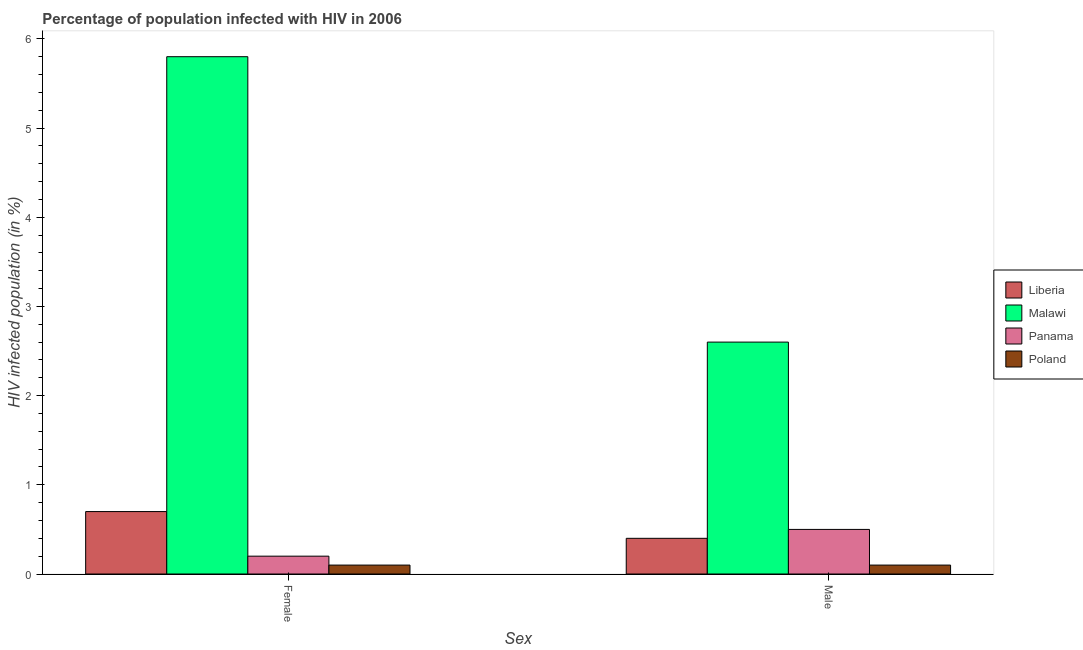Are the number of bars per tick equal to the number of legend labels?
Offer a very short reply. Yes. Are the number of bars on each tick of the X-axis equal?
Make the answer very short. Yes. How many bars are there on the 2nd tick from the left?
Your answer should be compact. 4. What is the label of the 2nd group of bars from the left?
Provide a succinct answer. Male. Across all countries, what is the minimum percentage of females who are infected with hiv?
Your answer should be compact. 0.1. In which country was the percentage of females who are infected with hiv maximum?
Make the answer very short. Malawi. In which country was the percentage of males who are infected with hiv minimum?
Give a very brief answer. Poland. What is the difference between the percentage of males who are infected with hiv in Poland and that in Liberia?
Provide a short and direct response. -0.3. What is the difference between the percentage of females who are infected with hiv in Liberia and the percentage of males who are infected with hiv in Panama?
Offer a very short reply. 0.2. What is the average percentage of females who are infected with hiv per country?
Your response must be concise. 1.7. In how many countries, is the percentage of females who are infected with hiv greater than 4.4 %?
Provide a short and direct response. 1. What is the ratio of the percentage of females who are infected with hiv in Malawi to that in Panama?
Offer a terse response. 29. In how many countries, is the percentage of males who are infected with hiv greater than the average percentage of males who are infected with hiv taken over all countries?
Your answer should be compact. 1. What does the 1st bar from the left in Female represents?
Offer a terse response. Liberia. What does the 3rd bar from the right in Male represents?
Offer a very short reply. Malawi. Are the values on the major ticks of Y-axis written in scientific E-notation?
Your answer should be very brief. No. What is the title of the graph?
Ensure brevity in your answer.  Percentage of population infected with HIV in 2006. Does "Korea (Democratic)" appear as one of the legend labels in the graph?
Keep it short and to the point. No. What is the label or title of the X-axis?
Provide a short and direct response. Sex. What is the label or title of the Y-axis?
Ensure brevity in your answer.  HIV infected population (in %). What is the HIV infected population (in %) of Malawi in Female?
Make the answer very short. 5.8. What is the HIV infected population (in %) of Poland in Female?
Offer a very short reply. 0.1. Across all Sex, what is the maximum HIV infected population (in %) of Malawi?
Provide a succinct answer. 5.8. Across all Sex, what is the minimum HIV infected population (in %) in Liberia?
Offer a very short reply. 0.4. Across all Sex, what is the minimum HIV infected population (in %) in Malawi?
Your answer should be compact. 2.6. Across all Sex, what is the minimum HIV infected population (in %) in Poland?
Provide a succinct answer. 0.1. What is the total HIV infected population (in %) of Panama in the graph?
Your answer should be very brief. 0.7. What is the total HIV infected population (in %) in Poland in the graph?
Your response must be concise. 0.2. What is the difference between the HIV infected population (in %) of Malawi in Female and that in Male?
Keep it short and to the point. 3.2. What is the difference between the HIV infected population (in %) in Panama in Female and that in Male?
Offer a very short reply. -0.3. What is the difference between the HIV infected population (in %) in Malawi in Female and the HIV infected population (in %) in Panama in Male?
Your response must be concise. 5.3. What is the average HIV infected population (in %) of Liberia per Sex?
Your answer should be compact. 0.55. What is the average HIV infected population (in %) of Panama per Sex?
Your answer should be very brief. 0.35. What is the difference between the HIV infected population (in %) of Liberia and HIV infected population (in %) of Malawi in Female?
Ensure brevity in your answer.  -5.1. What is the difference between the HIV infected population (in %) in Liberia and HIV infected population (in %) in Poland in Female?
Your answer should be very brief. 0.6. What is the difference between the HIV infected population (in %) in Malawi and HIV infected population (in %) in Poland in Female?
Your answer should be very brief. 5.7. What is the difference between the HIV infected population (in %) in Panama and HIV infected population (in %) in Poland in Female?
Provide a short and direct response. 0.1. What is the difference between the HIV infected population (in %) of Liberia and HIV infected population (in %) of Malawi in Male?
Your response must be concise. -2.2. What is the difference between the HIV infected population (in %) of Liberia and HIV infected population (in %) of Panama in Male?
Offer a terse response. -0.1. What is the difference between the HIV infected population (in %) in Malawi and HIV infected population (in %) in Panama in Male?
Provide a succinct answer. 2.1. What is the difference between the HIV infected population (in %) in Panama and HIV infected population (in %) in Poland in Male?
Your response must be concise. 0.4. What is the ratio of the HIV infected population (in %) of Malawi in Female to that in Male?
Provide a short and direct response. 2.23. What is the ratio of the HIV infected population (in %) in Panama in Female to that in Male?
Offer a very short reply. 0.4. What is the difference between the highest and the second highest HIV infected population (in %) in Poland?
Provide a short and direct response. 0. What is the difference between the highest and the lowest HIV infected population (in %) of Malawi?
Provide a succinct answer. 3.2. What is the difference between the highest and the lowest HIV infected population (in %) of Poland?
Provide a succinct answer. 0. 